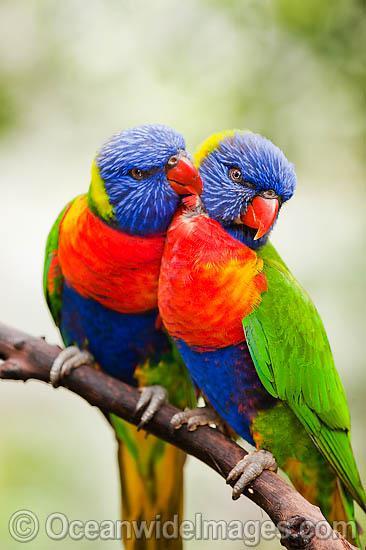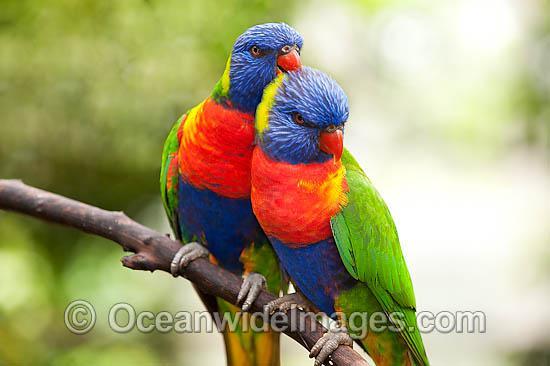The first image is the image on the left, the second image is the image on the right. Examine the images to the left and right. Is the description "At least one image shows a colorful bird with its wings spread" accurate? Answer yes or no. No. The first image is the image on the left, the second image is the image on the right. Assess this claim about the two images: "There are four birds perched together in groups of two.". Correct or not? Answer yes or no. Yes. 